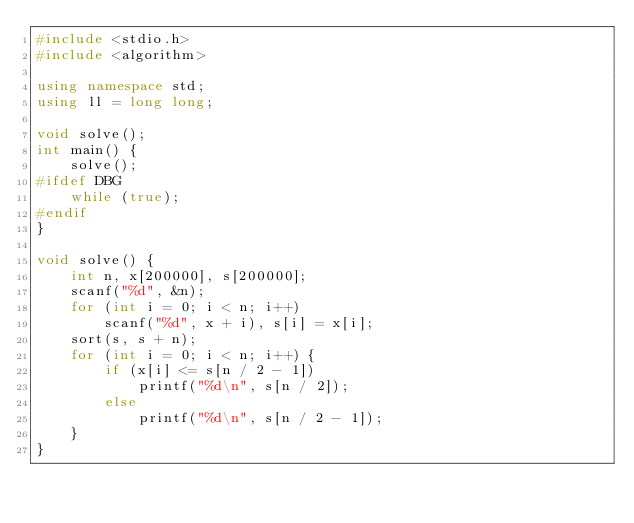<code> <loc_0><loc_0><loc_500><loc_500><_C++_>#include <stdio.h>
#include <algorithm>

using namespace std;
using ll = long long;

void solve();
int main() {
	solve();
#ifdef DBG
	while (true);
#endif
}

void solve() {
	int n, x[200000], s[200000];
	scanf("%d", &n);
	for (int i = 0; i < n; i++)
		scanf("%d", x + i), s[i] = x[i];
	sort(s, s + n);
	for (int i = 0; i < n; i++) {
		if (x[i] <= s[n / 2 - 1])
			printf("%d\n", s[n / 2]);
		else
			printf("%d\n", s[n / 2 - 1]);
	}
}</code> 